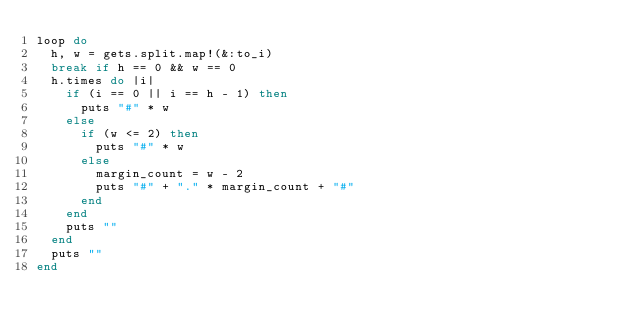<code> <loc_0><loc_0><loc_500><loc_500><_Ruby_>loop do 
  h, w = gets.split.map!(&:to_i)
  break if h == 0 && w == 0
  h.times do |i|
    if (i == 0 || i == h - 1) then 
      puts "#" * w
    else
      if (w <= 2) then
        puts "#" * w 
      else
        margin_count = w - 2
        puts "#" + "." * margin_count + "#"
      end
    end
    puts ""
  end
  puts ""
end</code> 